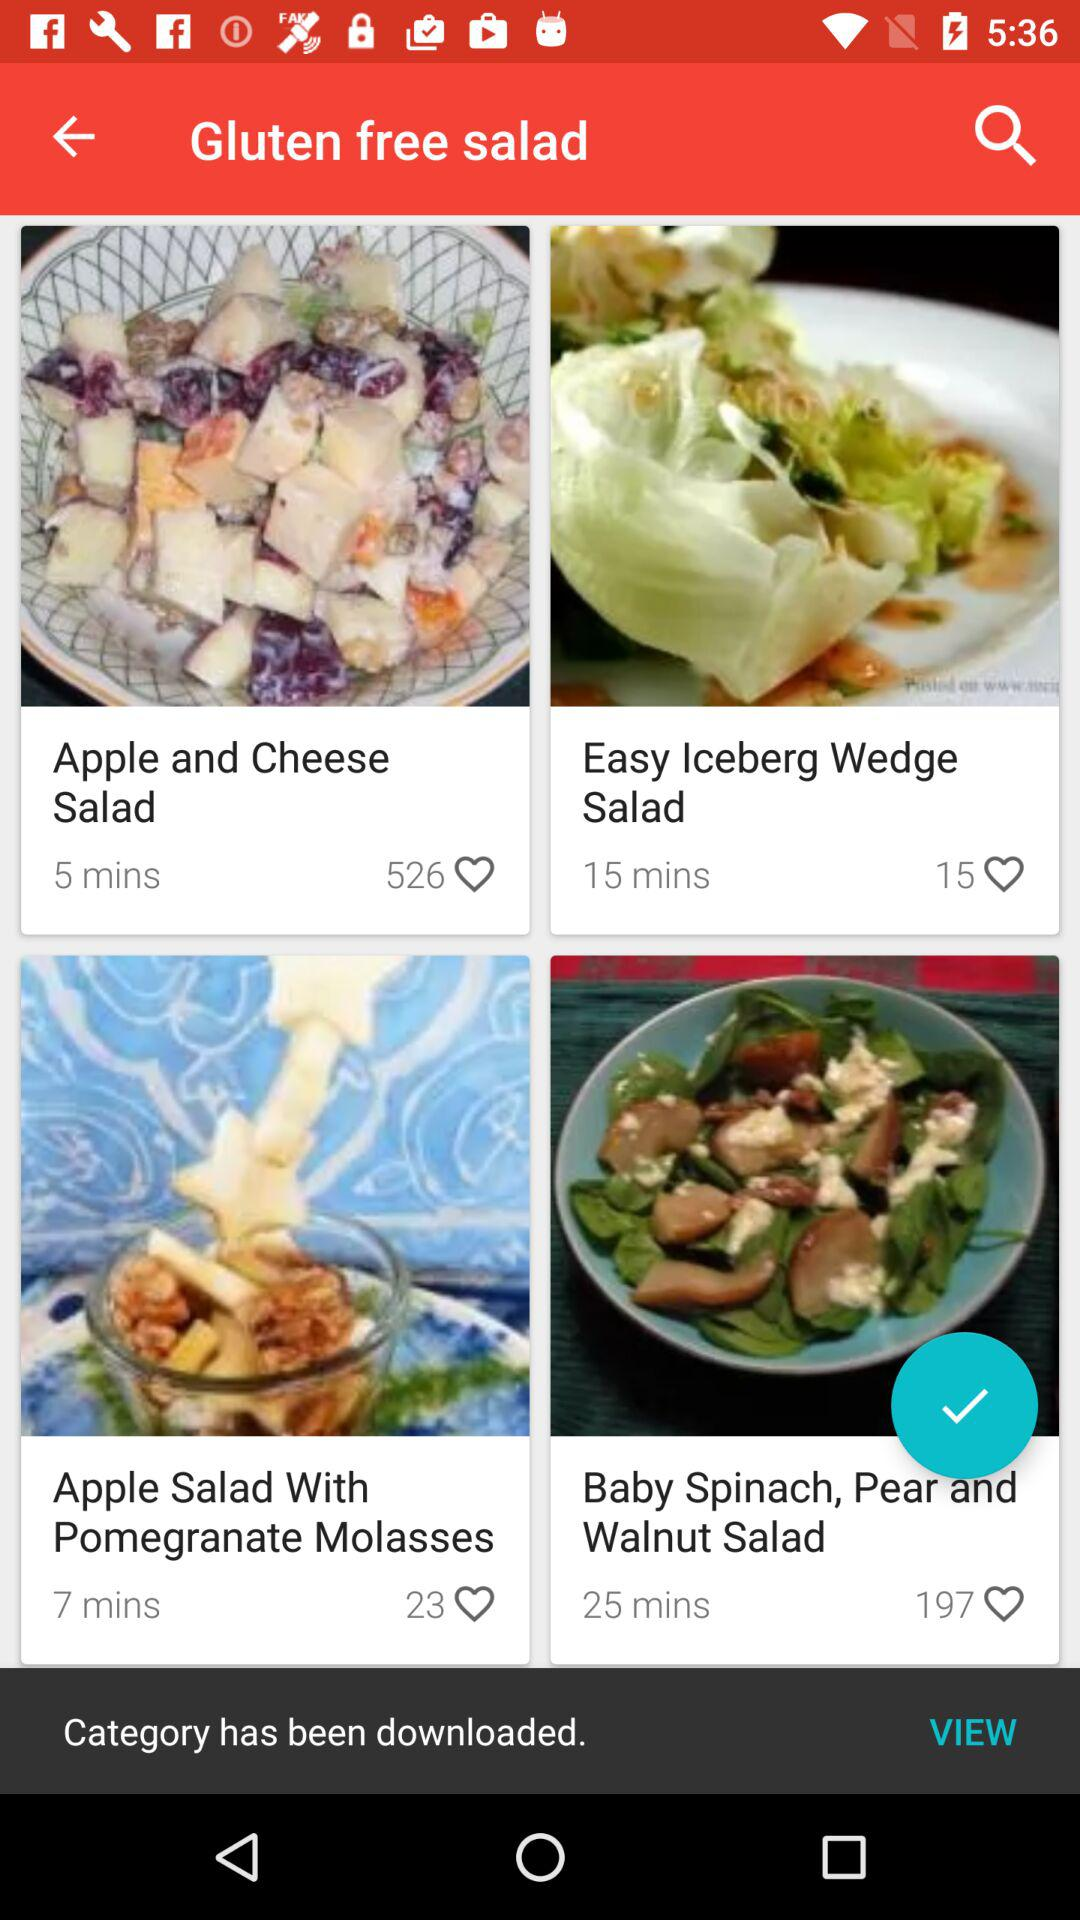How many likes did the "Apple and Cheese Salad" get? The "Apple and Cheese Salad" got 526 likes. 